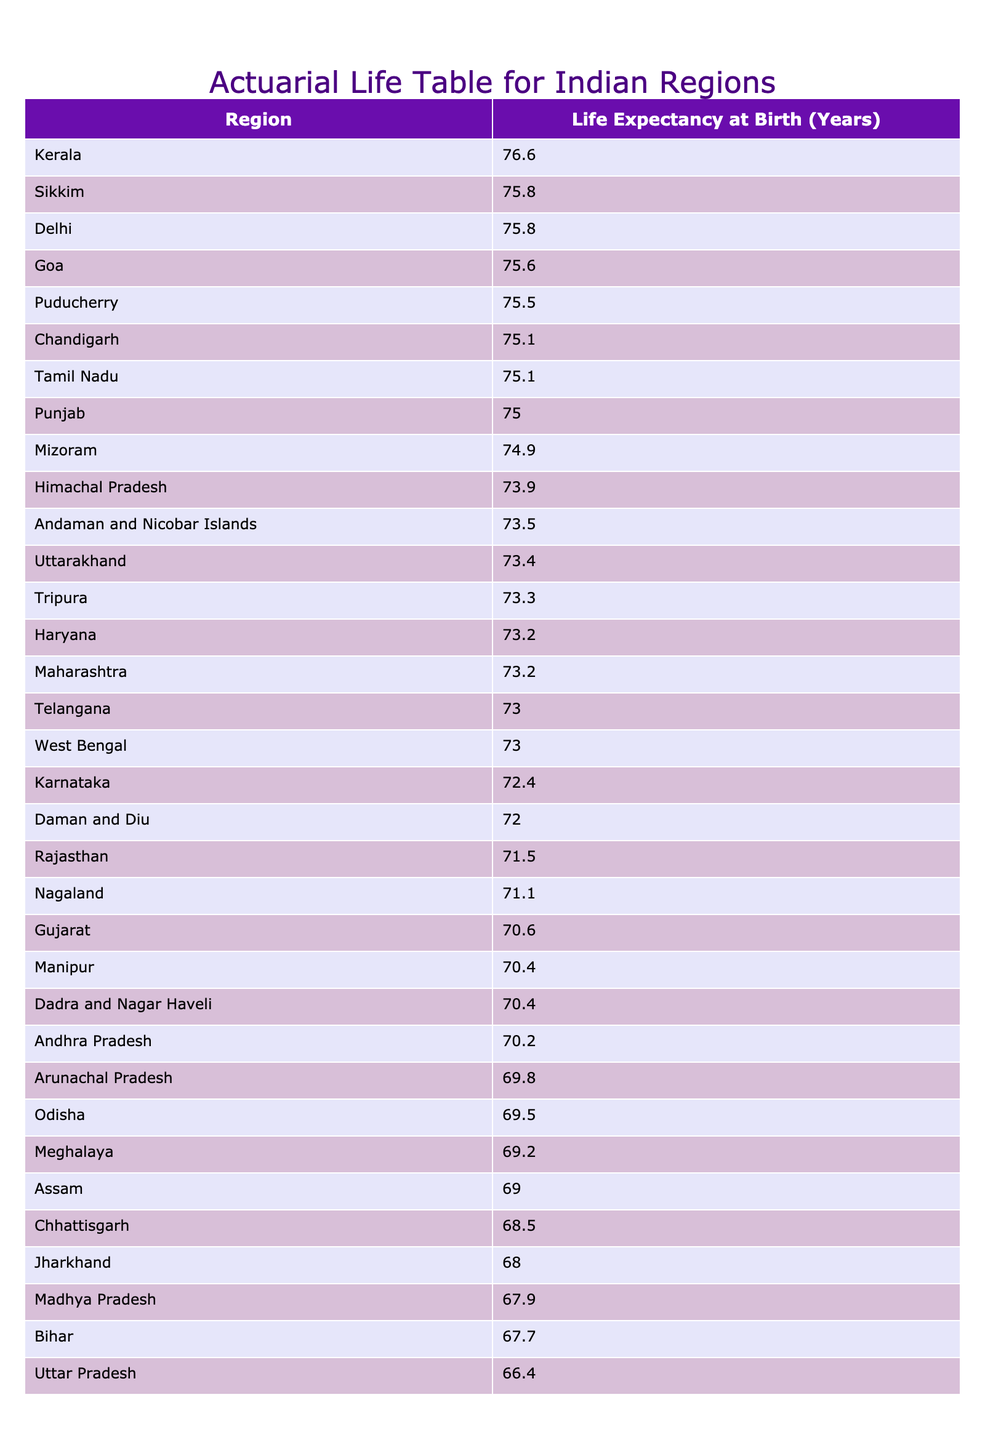What is the life expectancy at birth in Kerala? The table shows that Kerala has a life expectancy at birth of 76.6 years, which is specifically listed under the corresponding region.
Answer: 76.6 Which region has the lowest life expectancy at birth? By examining the table, it can be observed that Uttar Pradesh has the lowest life expectancy at birth, listed as 66.4 years.
Answer: Uttar Pradesh What is the difference in life expectancy at birth between Chandigarh and Maharashtra? From the table, Chandigarh has a life expectancy at birth of 75.1 years, while Maharashtra has 73.2 years. The difference can be calculated as 75.1 - 73.2 = 1.9 years.
Answer: 1.9 Which two regions have a life expectancy at birth greater than 75 years? By checking the table, we find that Kerala (76.6 years) and Delhi (75.8 years) both have life expectancies greater than 75 years.
Answer: Kerala and Delhi Is the life expectancy at birth in Goa higher than that of Bihar? From the data, Goa has a life expectancy of 75.6 years while Bihar has 67.7 years. Since 75.6 is greater than 67.7, the statement is true.
Answer: Yes What is the average life expectancy at birth of the northeastern regions: Assam, Manipur, and Meghalaya? The life expectancies for Assam, Manipur, and Meghalaya are 69.0, 70.4, and 69.2 years respectively. To find the average, we sum them up (69.0 + 70.4 + 69.2) = 208.6 years and then divide by 3, which gives us approximately 69.53 years.
Answer: 69.53 Which region has a life expectancy at birth that is closest to the average life expectancy of 72 years? Looking at the table, we need to determine which value is closest to 72. The values of Karnataka (72.4), Telangana (73.0), and Tamil Nadu (75.1) are the nearest. Among these, Karnataka has the smallest difference from 72, as it is only 0.4 higher.
Answer: Karnataka How many regions in India have a life expectancy at birth lower than 70 years? By reviewing the table, we identify the regions below 70 years: Bihar (67.7), Jharkhand (68.0), and Assam (69.0). Counting these gives us a total of 3 regions.
Answer: 3 regions What is the life expectancy data trend of southern states (Andhra Pradesh, Karnataka, Kerala, Tamil Nadu)? The life expectancies are as follows: Andhra Pradesh (70.2), Karnataka (72.4), Kerala (76.6), and Tamil Nadu (75.1). The trend shows an increase from Andhra Pradesh to Kerala, indicating that southern states tend to have higher life expectancies with Kerala having the highest among them.
Answer: Increase trend 